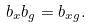Convert formula to latex. <formula><loc_0><loc_0><loc_500><loc_500>b _ { x } b _ { g } = b _ { x g } .</formula> 